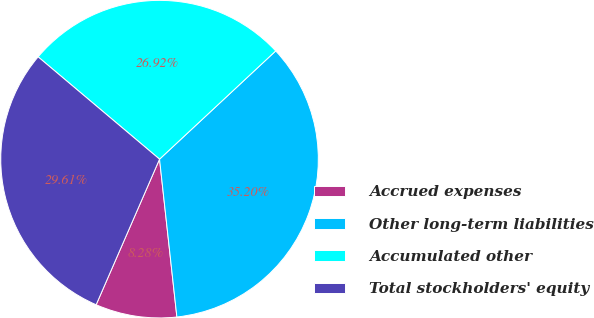Convert chart. <chart><loc_0><loc_0><loc_500><loc_500><pie_chart><fcel>Accrued expenses<fcel>Other long-term liabilities<fcel>Accumulated other<fcel>Total stockholders' equity<nl><fcel>8.28%<fcel>35.2%<fcel>26.92%<fcel>29.61%<nl></chart> 